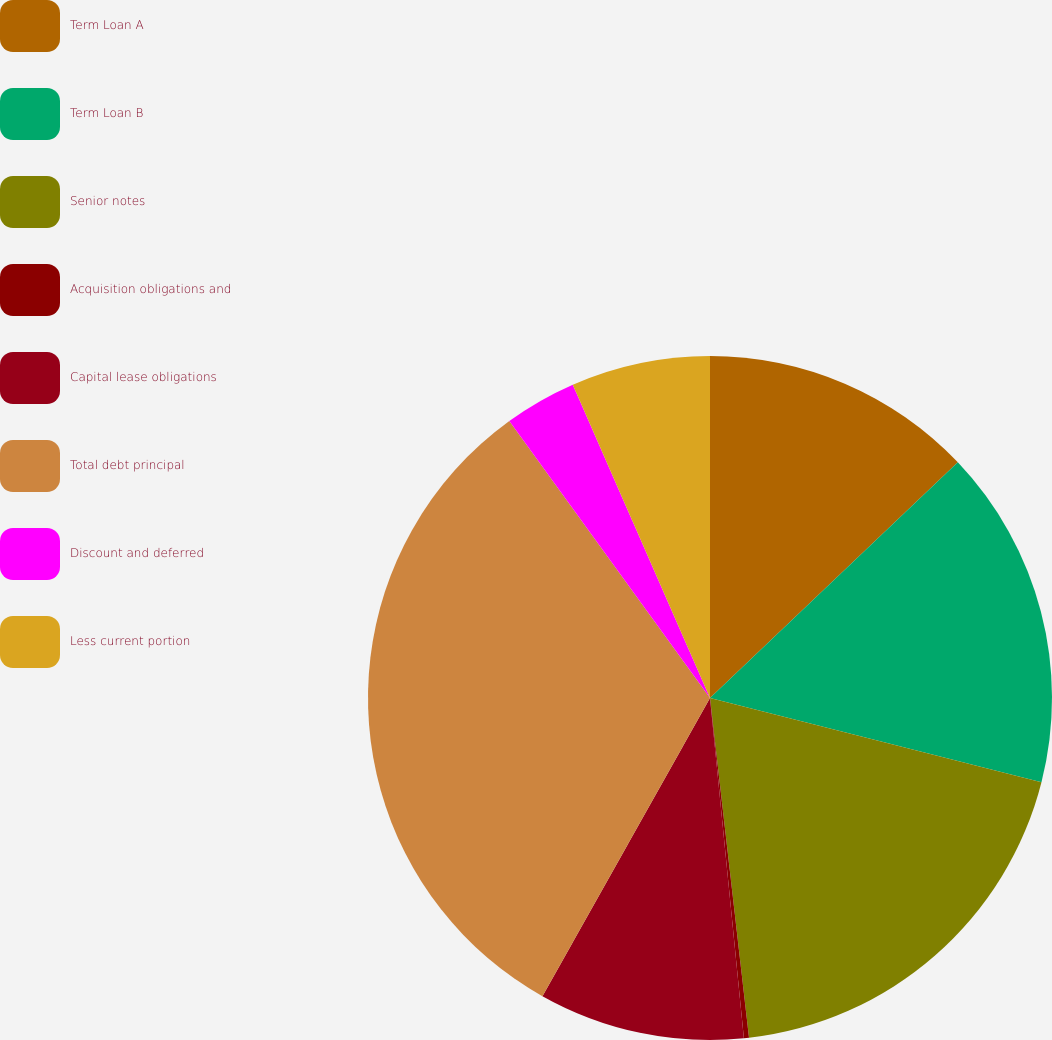Convert chart. <chart><loc_0><loc_0><loc_500><loc_500><pie_chart><fcel>Term Loan A<fcel>Term Loan B<fcel>Senior notes<fcel>Acquisition obligations and<fcel>Capital lease obligations<fcel>Total debt principal<fcel>Discount and deferred<fcel>Less current portion<nl><fcel>12.9%<fcel>16.06%<fcel>19.22%<fcel>0.24%<fcel>9.73%<fcel>31.87%<fcel>3.41%<fcel>6.57%<nl></chart> 